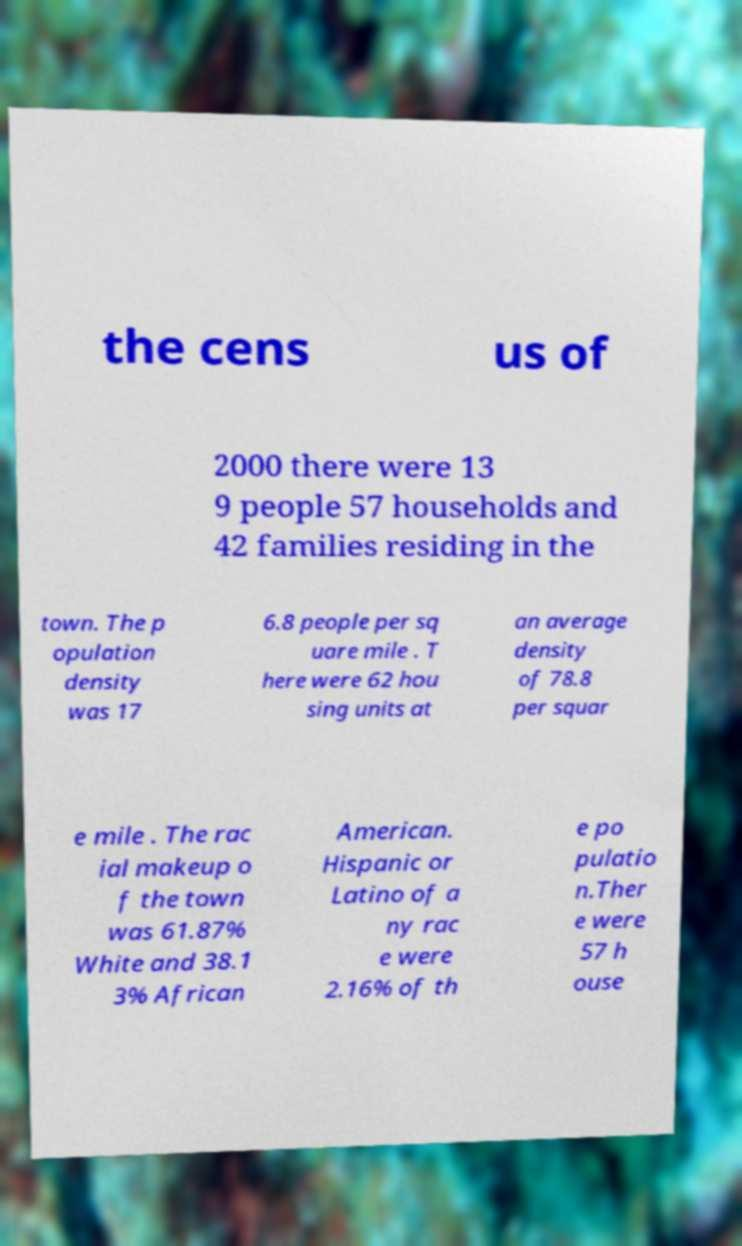Could you extract and type out the text from this image? the cens us of 2000 there were 13 9 people 57 households and 42 families residing in the town. The p opulation density was 17 6.8 people per sq uare mile . T here were 62 hou sing units at an average density of 78.8 per squar e mile . The rac ial makeup o f the town was 61.87% White and 38.1 3% African American. Hispanic or Latino of a ny rac e were 2.16% of th e po pulatio n.Ther e were 57 h ouse 